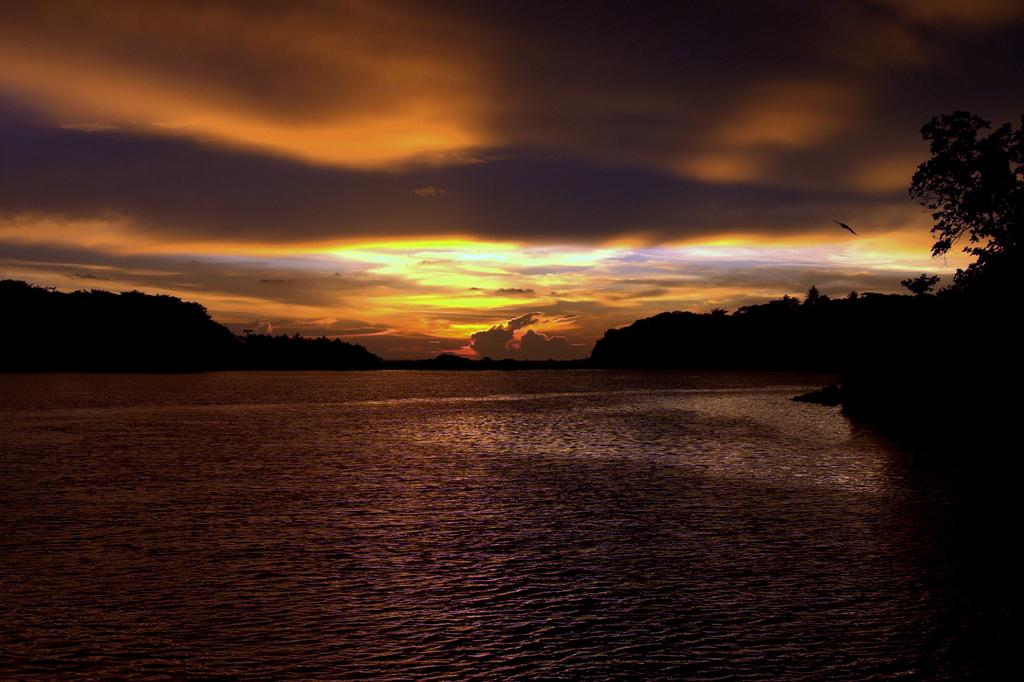What type of natural landform can be seen in the image? There are mountains in the image. What type of vegetation is present in the image? There are trees in the image. How would you describe the sky in the image? The sky is cloudy in the image. What body of water is visible at the bottom of the image? There is a sea at the bottom of the image. How many pairs of shoes can be seen in the image? There are no shoes present in the image. What type of farm animals can be seen grazing in the image? There are no farm animals, such as cows, present in the image. 